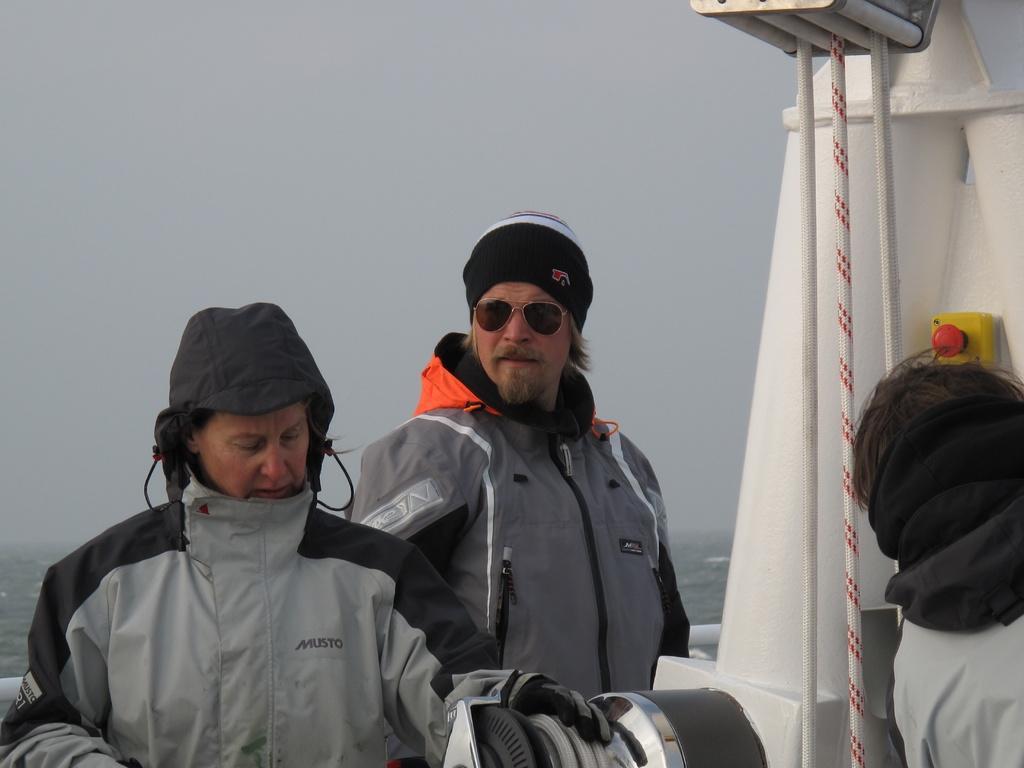Can you describe this image briefly? In this picture I can observe three members in the boat. One of them is wearing spectacles. In the background I can observe sky. 